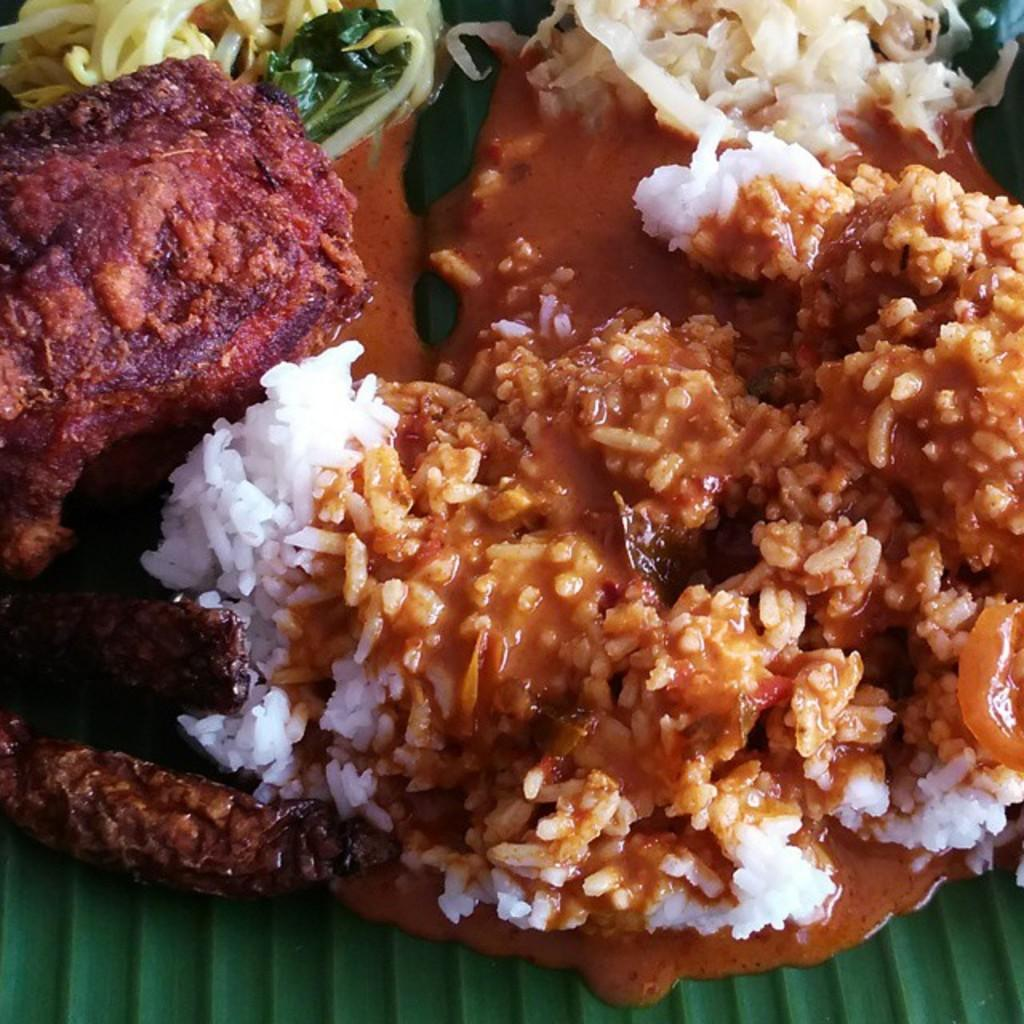What type of objects can be seen in the image? There are food items in the image. What is the color of the surface on which the food items are placed? The surface is green in color. What type of pig is featured in the advertisement in the image? There is no pig or advertisement present in the image; it only contains food items on a green surface. 